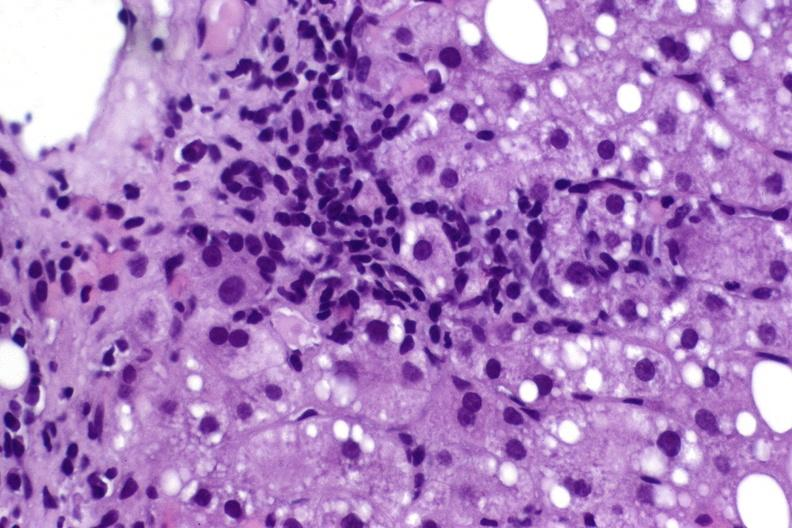does this image show hepatitis c virus?
Answer the question using a single word or phrase. Yes 